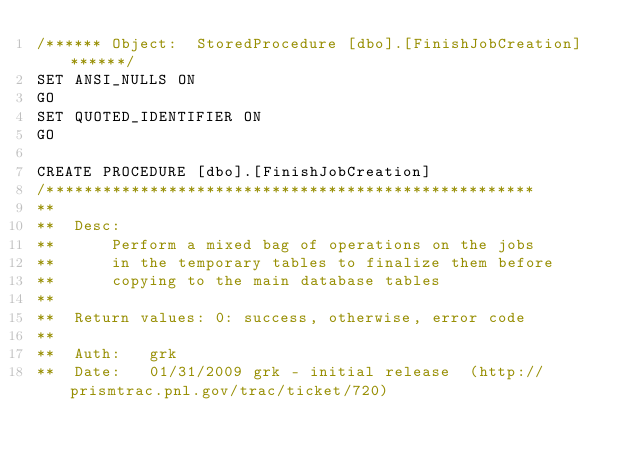<code> <loc_0><loc_0><loc_500><loc_500><_SQL_>/****** Object:  StoredProcedure [dbo].[FinishJobCreation] ******/
SET ANSI_NULLS ON
GO
SET QUOTED_IDENTIFIER ON
GO

CREATE PROCEDURE [dbo].[FinishJobCreation]
/****************************************************
**
**  Desc: 
**      Perform a mixed bag of operations on the jobs
**      in the temporary tables to finalize them before
**      copying to the main database tables
**    
**  Return values: 0: success, otherwise, error code
**
**  Auth:   grk
**  Date:   01/31/2009 grk - initial release  (http://prismtrac.pnl.gov/trac/ticket/720)</code> 